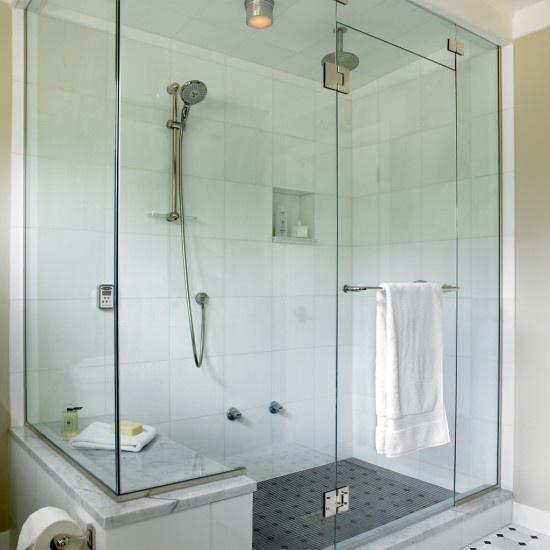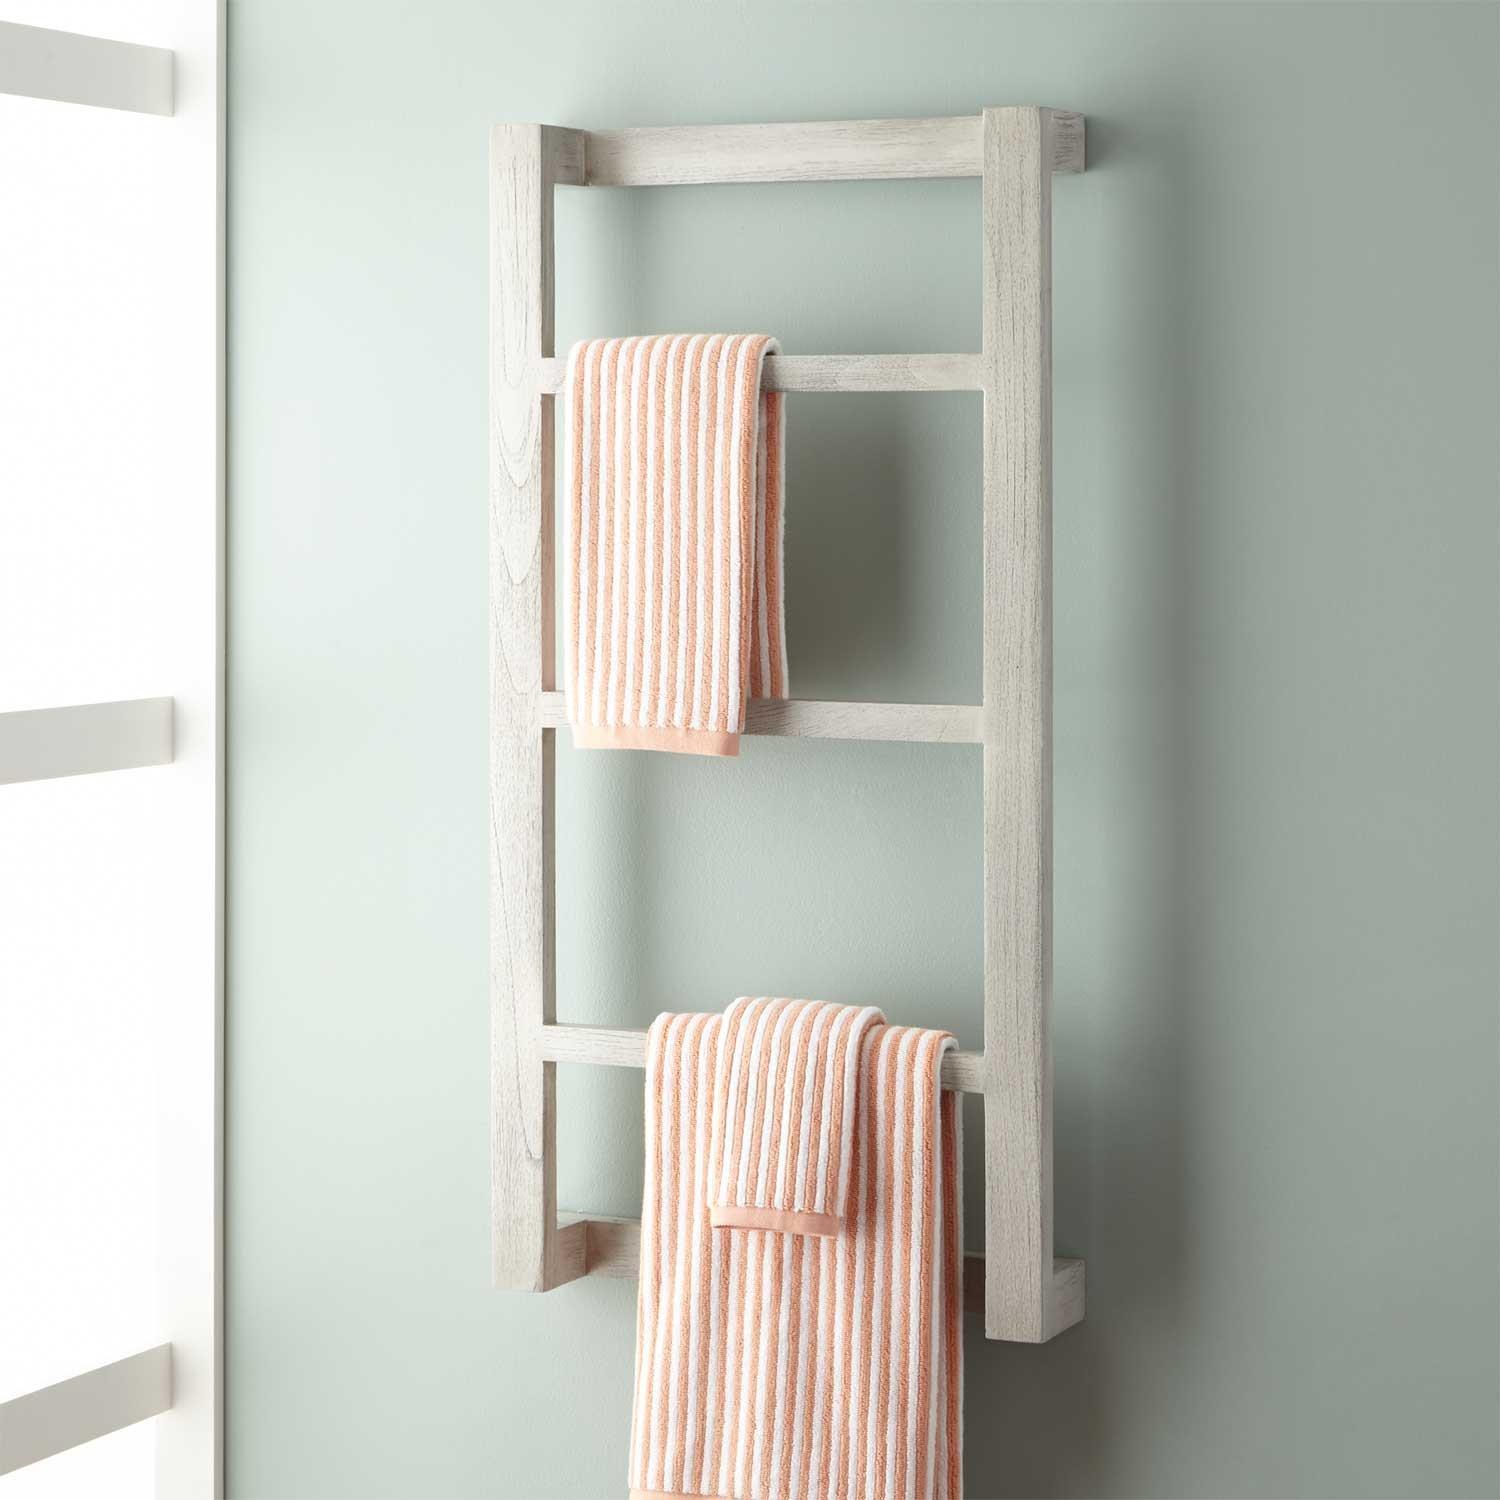The first image is the image on the left, the second image is the image on the right. Given the left and right images, does the statement "There is a blue towel hanging on an over the door rack" hold true? Answer yes or no. No. The first image is the image on the left, the second image is the image on the right. Considering the images on both sides, is "An image shows a light blue towel hanging on an over-the-door rack." valid? Answer yes or no. No. 